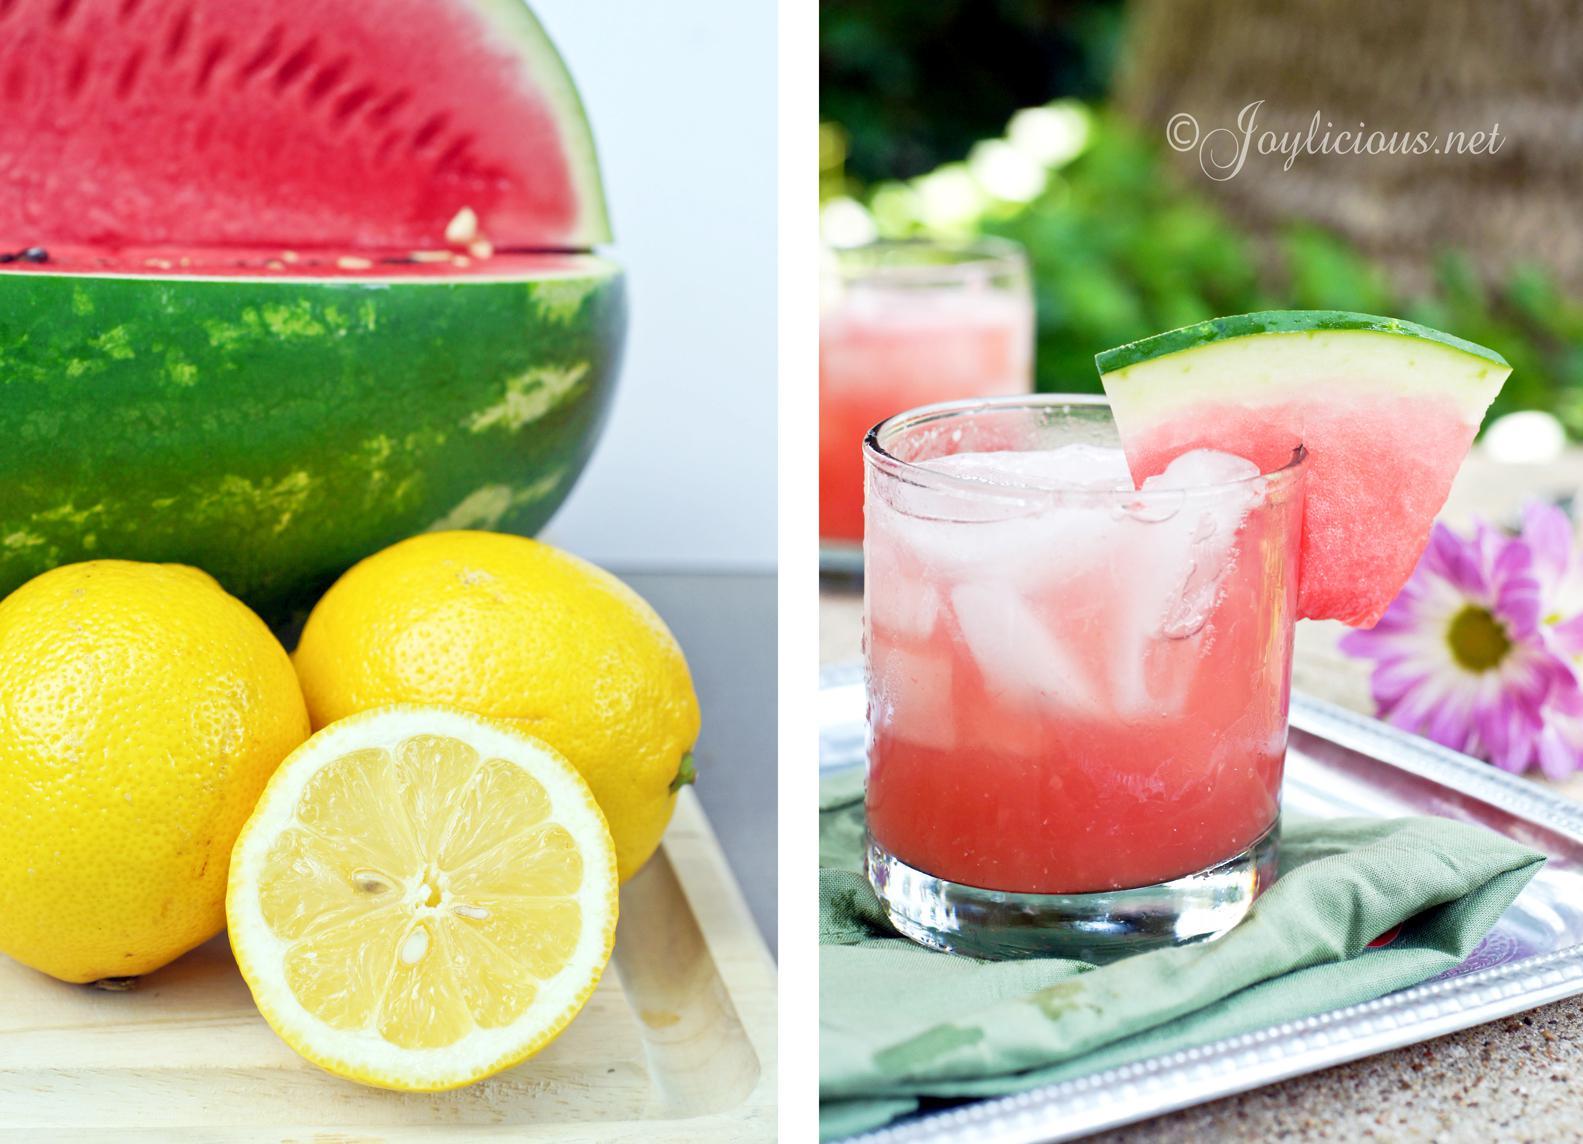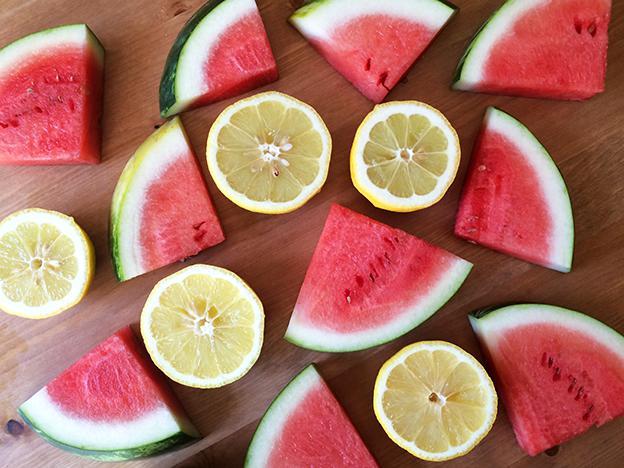The first image is the image on the left, the second image is the image on the right. For the images displayed, is the sentence "In one image, multiple watermelon wedges have green rind and white area next to the red fruit." factually correct? Answer yes or no. Yes. The first image is the image on the left, the second image is the image on the right. Analyze the images presented: Is the assertion "One image shows fruit in a white bowl." valid? Answer yes or no. No. 